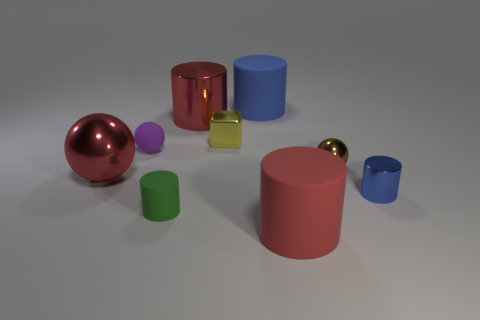How many yellow shiny things have the same shape as the small blue metal thing?
Make the answer very short. 0. Is the material of the red cylinder that is on the left side of the tiny yellow cube the same as the object that is in front of the small green rubber cylinder?
Provide a short and direct response. No. What size is the red object behind the tiny ball that is to the right of the small purple ball?
Offer a very short reply. Large. Is there any other thing that has the same size as the yellow shiny block?
Your response must be concise. Yes. There is another small thing that is the same shape as the tiny green object; what is it made of?
Offer a very short reply. Metal. Is the shape of the big rubber object that is behind the tiny green cylinder the same as the small rubber object that is behind the small green cylinder?
Your response must be concise. No. Are there more brown objects than large yellow matte balls?
Provide a succinct answer. Yes. What size is the brown ball?
Your response must be concise. Small. What number of other things are the same color as the large metal cylinder?
Keep it short and to the point. 2. Is the material of the large red thing behind the tiny brown ball the same as the green object?
Offer a very short reply. No. 